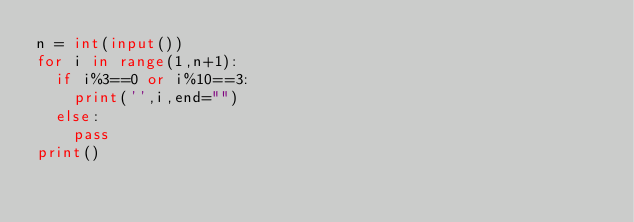Convert code to text. <code><loc_0><loc_0><loc_500><loc_500><_Python_>n = int(input())
for i in range(1,n+1):
  if i%3==0 or i%10==3:
    print('',i,end="")
  else:
    pass
print()
</code> 